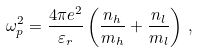Convert formula to latex. <formula><loc_0><loc_0><loc_500><loc_500>\omega _ { p } ^ { 2 } = \frac { 4 \pi e ^ { 2 } } { \varepsilon _ { r } } \left ( \frac { n _ { h } } { m _ { h } } + \frac { n _ { l } } { m _ { l } } \right ) \, ,</formula> 